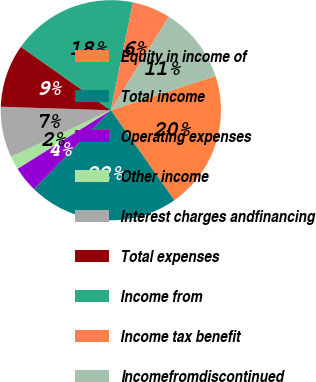Convert chart to OTSL. <chart><loc_0><loc_0><loc_500><loc_500><pie_chart><fcel>Equity in income of<fcel>Total income<fcel>Operating expenses<fcel>Other income<fcel>Interest charges andfinancing<fcel>Total expenses<fcel>Income from<fcel>Income tax benefit<fcel>Incomefromdiscontinued<nl><fcel>20.26%<fcel>22.08%<fcel>3.8%<fcel>1.97%<fcel>7.45%<fcel>9.28%<fcel>18.43%<fcel>5.62%<fcel>11.11%<nl></chart> 